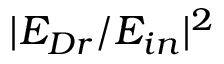Convert formula to latex. <formula><loc_0><loc_0><loc_500><loc_500>| E _ { D r } / E _ { i n } | ^ { 2 }</formula> 